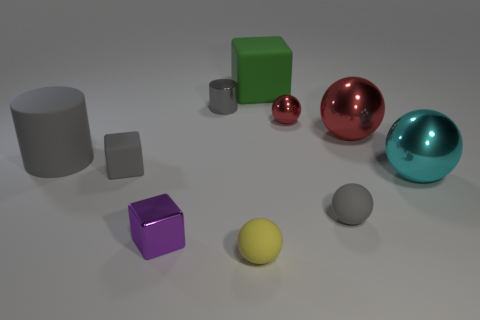Is the number of gray rubber blocks in front of the gray shiny cylinder less than the number of cyan spheres on the left side of the small gray rubber cube?
Your answer should be compact. No. There is a cube that is to the right of the small yellow rubber ball; what is its material?
Offer a terse response. Rubber. There is a matte ball that is the same color as the metal cylinder; what size is it?
Provide a short and direct response. Small. Are there any red blocks that have the same size as the gray metal object?
Offer a terse response. No. There is a tiny purple thing; is it the same shape as the big thing on the left side of the tiny shiny block?
Give a very brief answer. No. Is the size of the rubber object behind the matte cylinder the same as the cylinder that is on the right side of the rubber cylinder?
Provide a succinct answer. No. How many other things are the same shape as the green thing?
Offer a terse response. 2. What is the material of the large object that is left of the object that is in front of the small purple metallic object?
Your answer should be very brief. Rubber. How many shiny objects are either large red objects or big spheres?
Make the answer very short. 2. Are there any green rubber things that are to the right of the gray object that is on the right side of the yellow rubber thing?
Your answer should be compact. No. 